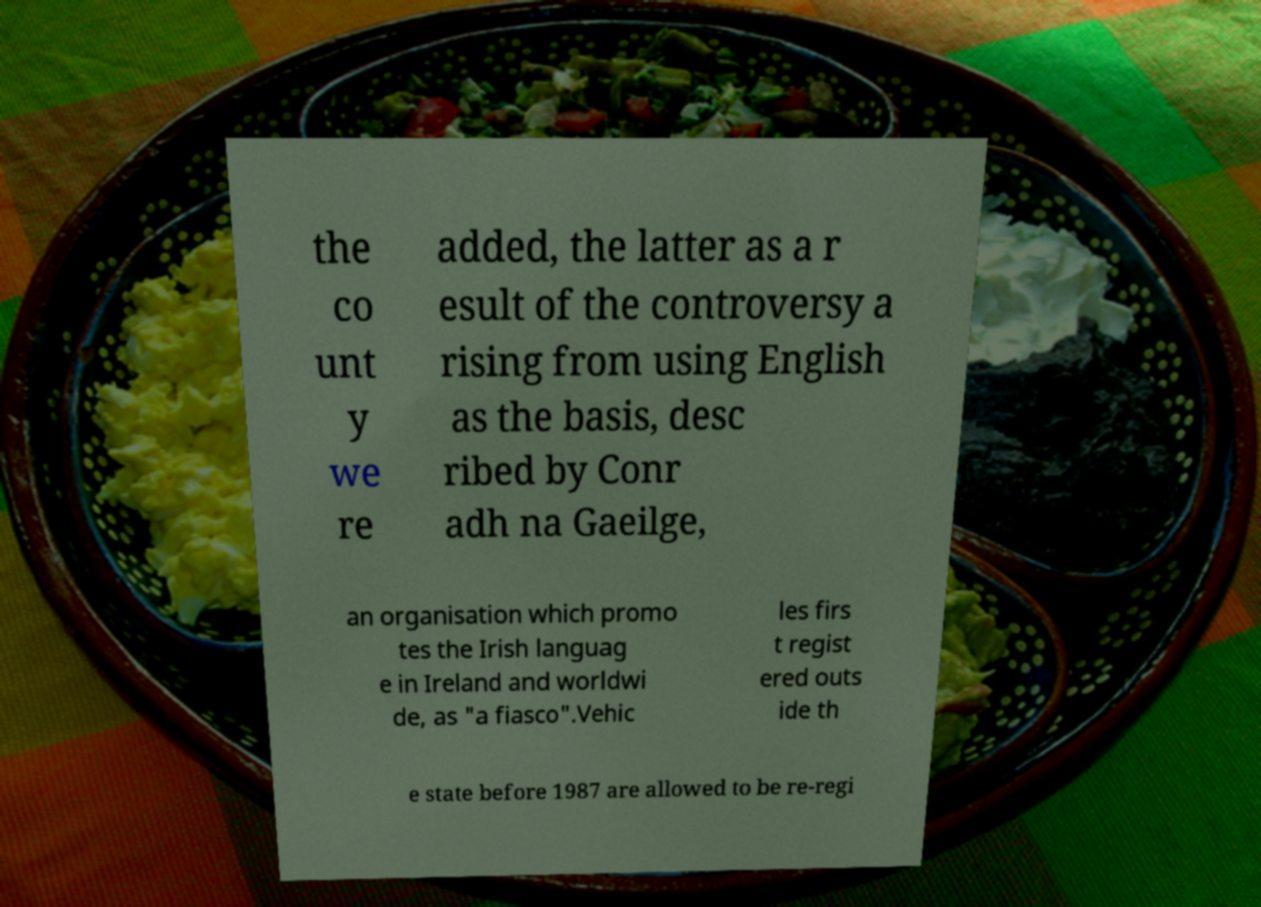Please read and relay the text visible in this image. What does it say? the co unt y we re added, the latter as a r esult of the controversy a rising from using English as the basis, desc ribed by Conr adh na Gaeilge, an organisation which promo tes the Irish languag e in Ireland and worldwi de, as "a fiasco".Vehic les firs t regist ered outs ide th e state before 1987 are allowed to be re-regi 